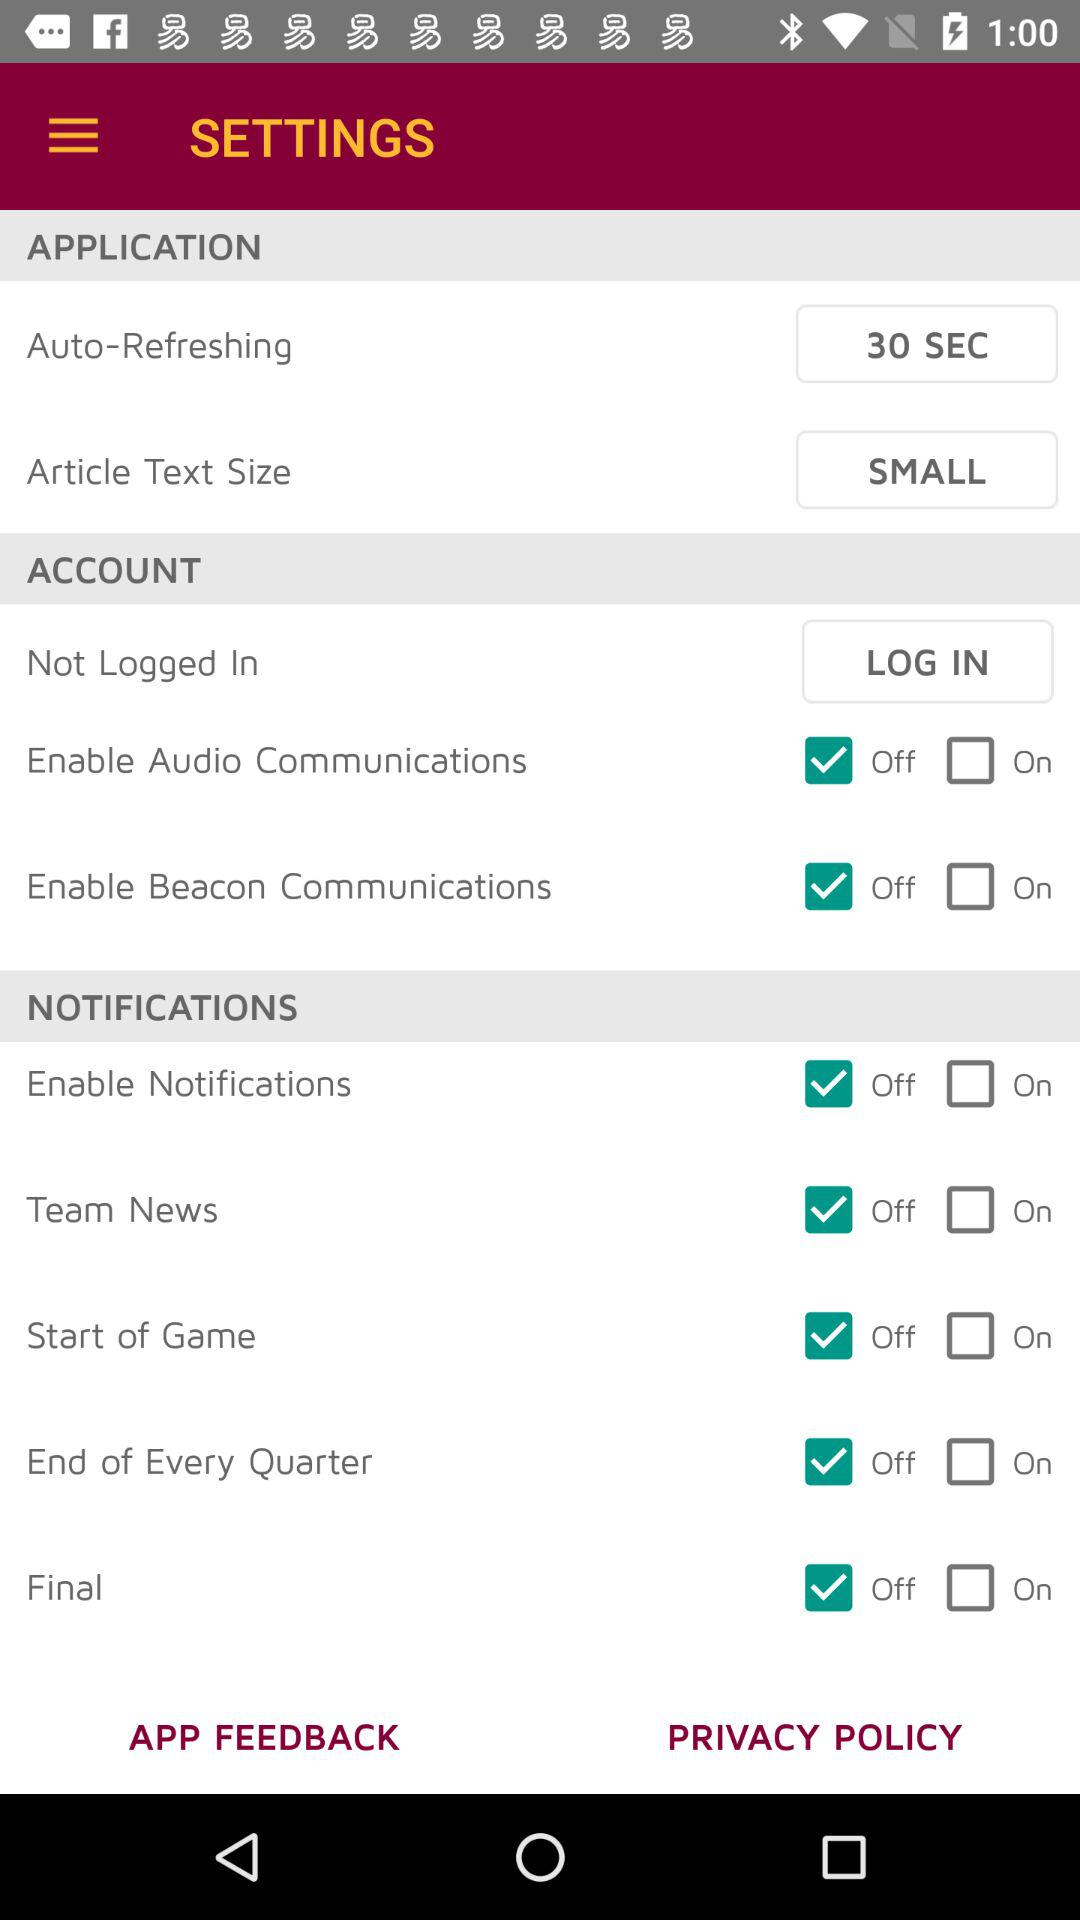What is the status of the "Final" notification? The status is "off". 